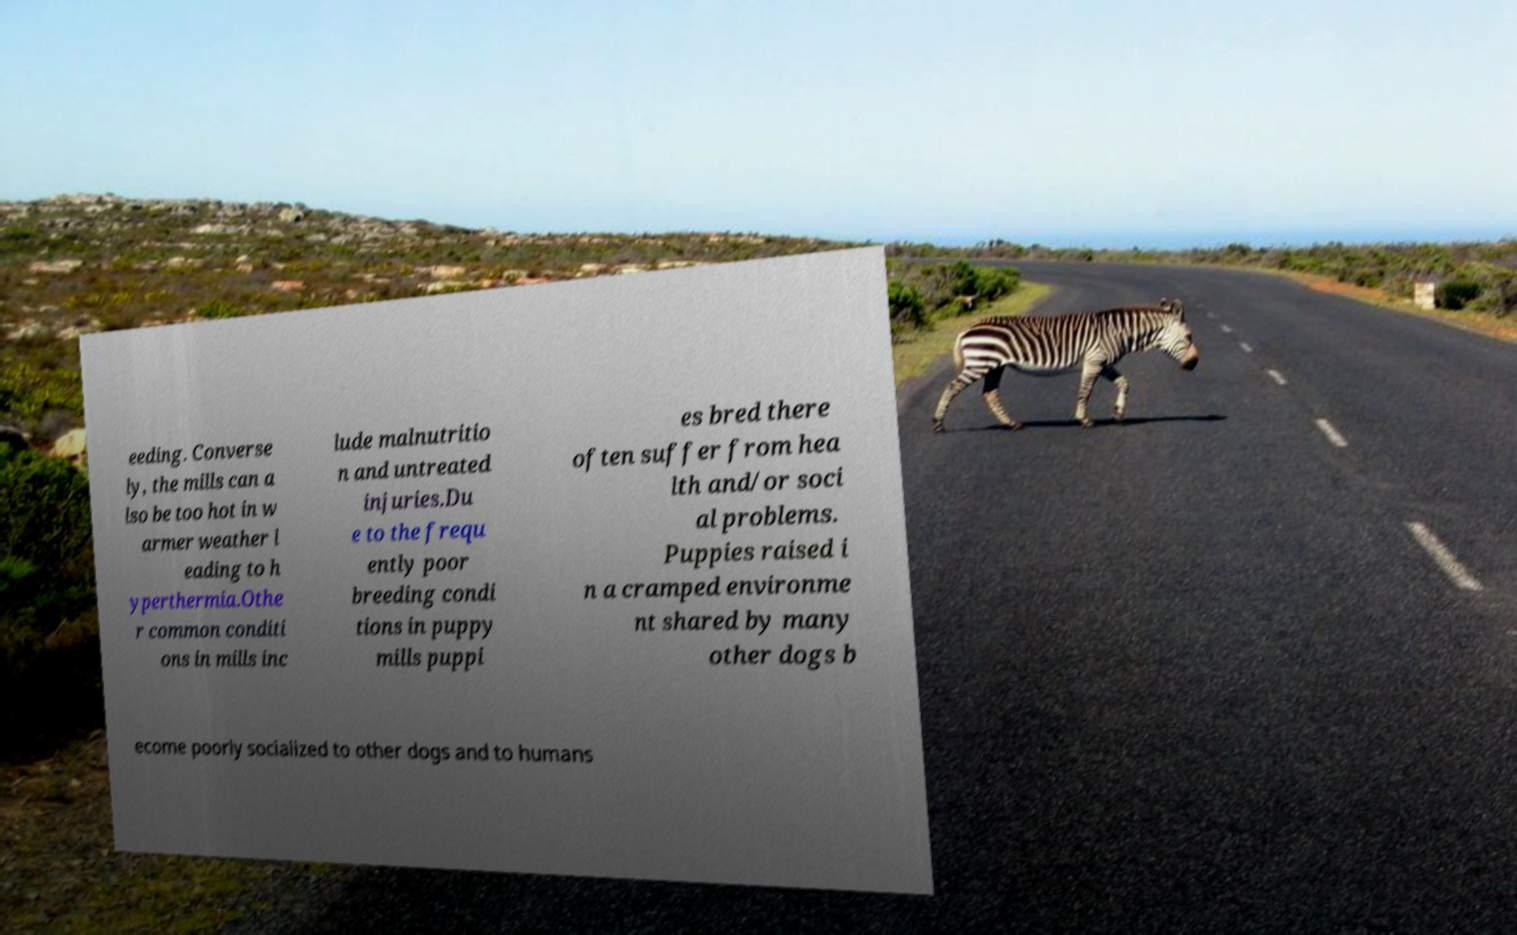What messages or text are displayed in this image? I need them in a readable, typed format. eeding. Converse ly, the mills can a lso be too hot in w armer weather l eading to h yperthermia.Othe r common conditi ons in mills inc lude malnutritio n and untreated injuries.Du e to the frequ ently poor breeding condi tions in puppy mills puppi es bred there often suffer from hea lth and/or soci al problems. Puppies raised i n a cramped environme nt shared by many other dogs b ecome poorly socialized to other dogs and to humans 